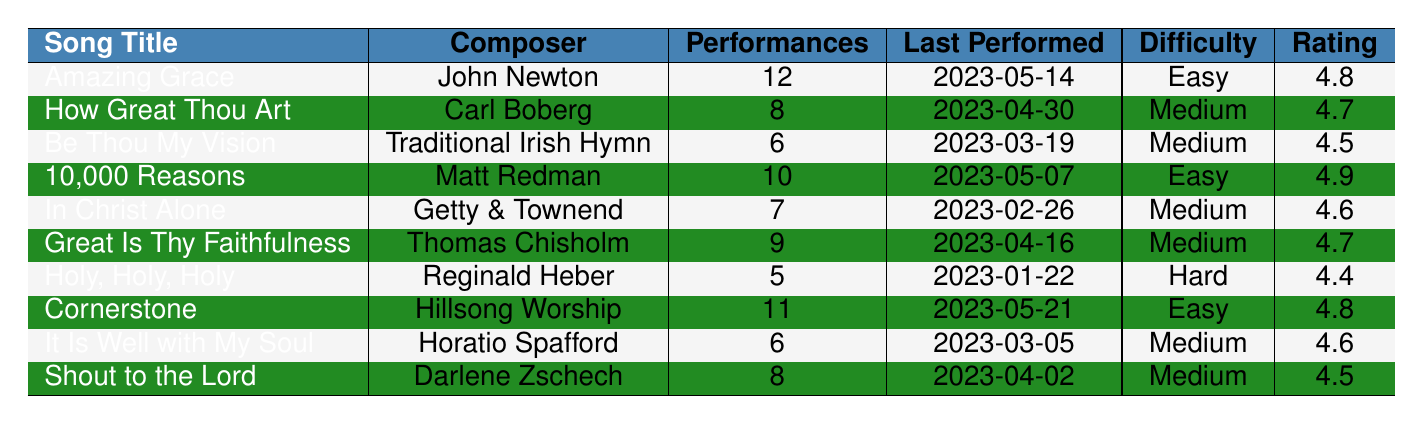What is the title of the song that has the highest congregation rating? From the table, we can see the congregation ratings for each song. The song "10,000 Reasons (Bless the Lord)" has the highest rating of 4.9.
Answer: 10,000 Reasons (Bless the Lord) Which song has been performed the least number of times? By looking at the 'Performances' column, we find that "Holy, Holy, Holy" has been performed only 5 times, which is the least compared to the other songs.
Answer: Holy, Holy, Holy What is the average rating of all the songs listed? To find the average, we add the ratings: (4.8 + 4.7 + 4.5 + 4.9 + 4.6 + 4.7 + 4.4 + 4.8 + 4.6 + 4.5) = 46.5. There are 10 songs, so the average is 46.5 / 10 = 4.65.
Answer: 4.65 How many songs have a difficulty level of "Easy"? Checking the 'Difficulty' column, we find that "Amazing Grace," "10,000 Reasons (Bless the Lord)," and "Cornerstone" are labeled as "Easy," which gives us a total of 3 songs.
Answer: 3 Which song was last performed on May 21, 2023? In the 'Last Performed' column, "Cornerstone" is listed with the date of May 21, 2023, so that is the song we are looking for.
Answer: Cornerstone Are there any songs rated lower than 4.5? By examining the ratings, we see that "Be Thou My Vision" (4.5) and "Holy, Holy, Holy" (4.4) fall below the threshold of 4.5, which confirms that there are songs rated lower.
Answer: Yes What is the difference in the number of performances between "Amazing Grace" and "Holy, Holy, Holy"? "Amazing Grace" has 12 performances, while "Holy, Holy, Holy" has 5. The difference is 12 - 5 = 7.
Answer: 7 Which composer has the song with the highest number of performances? "Amazing Grace" by John Newton has the highest number of performances (12) compared to others, making him the composer of the most performed song.
Answer: John Newton 